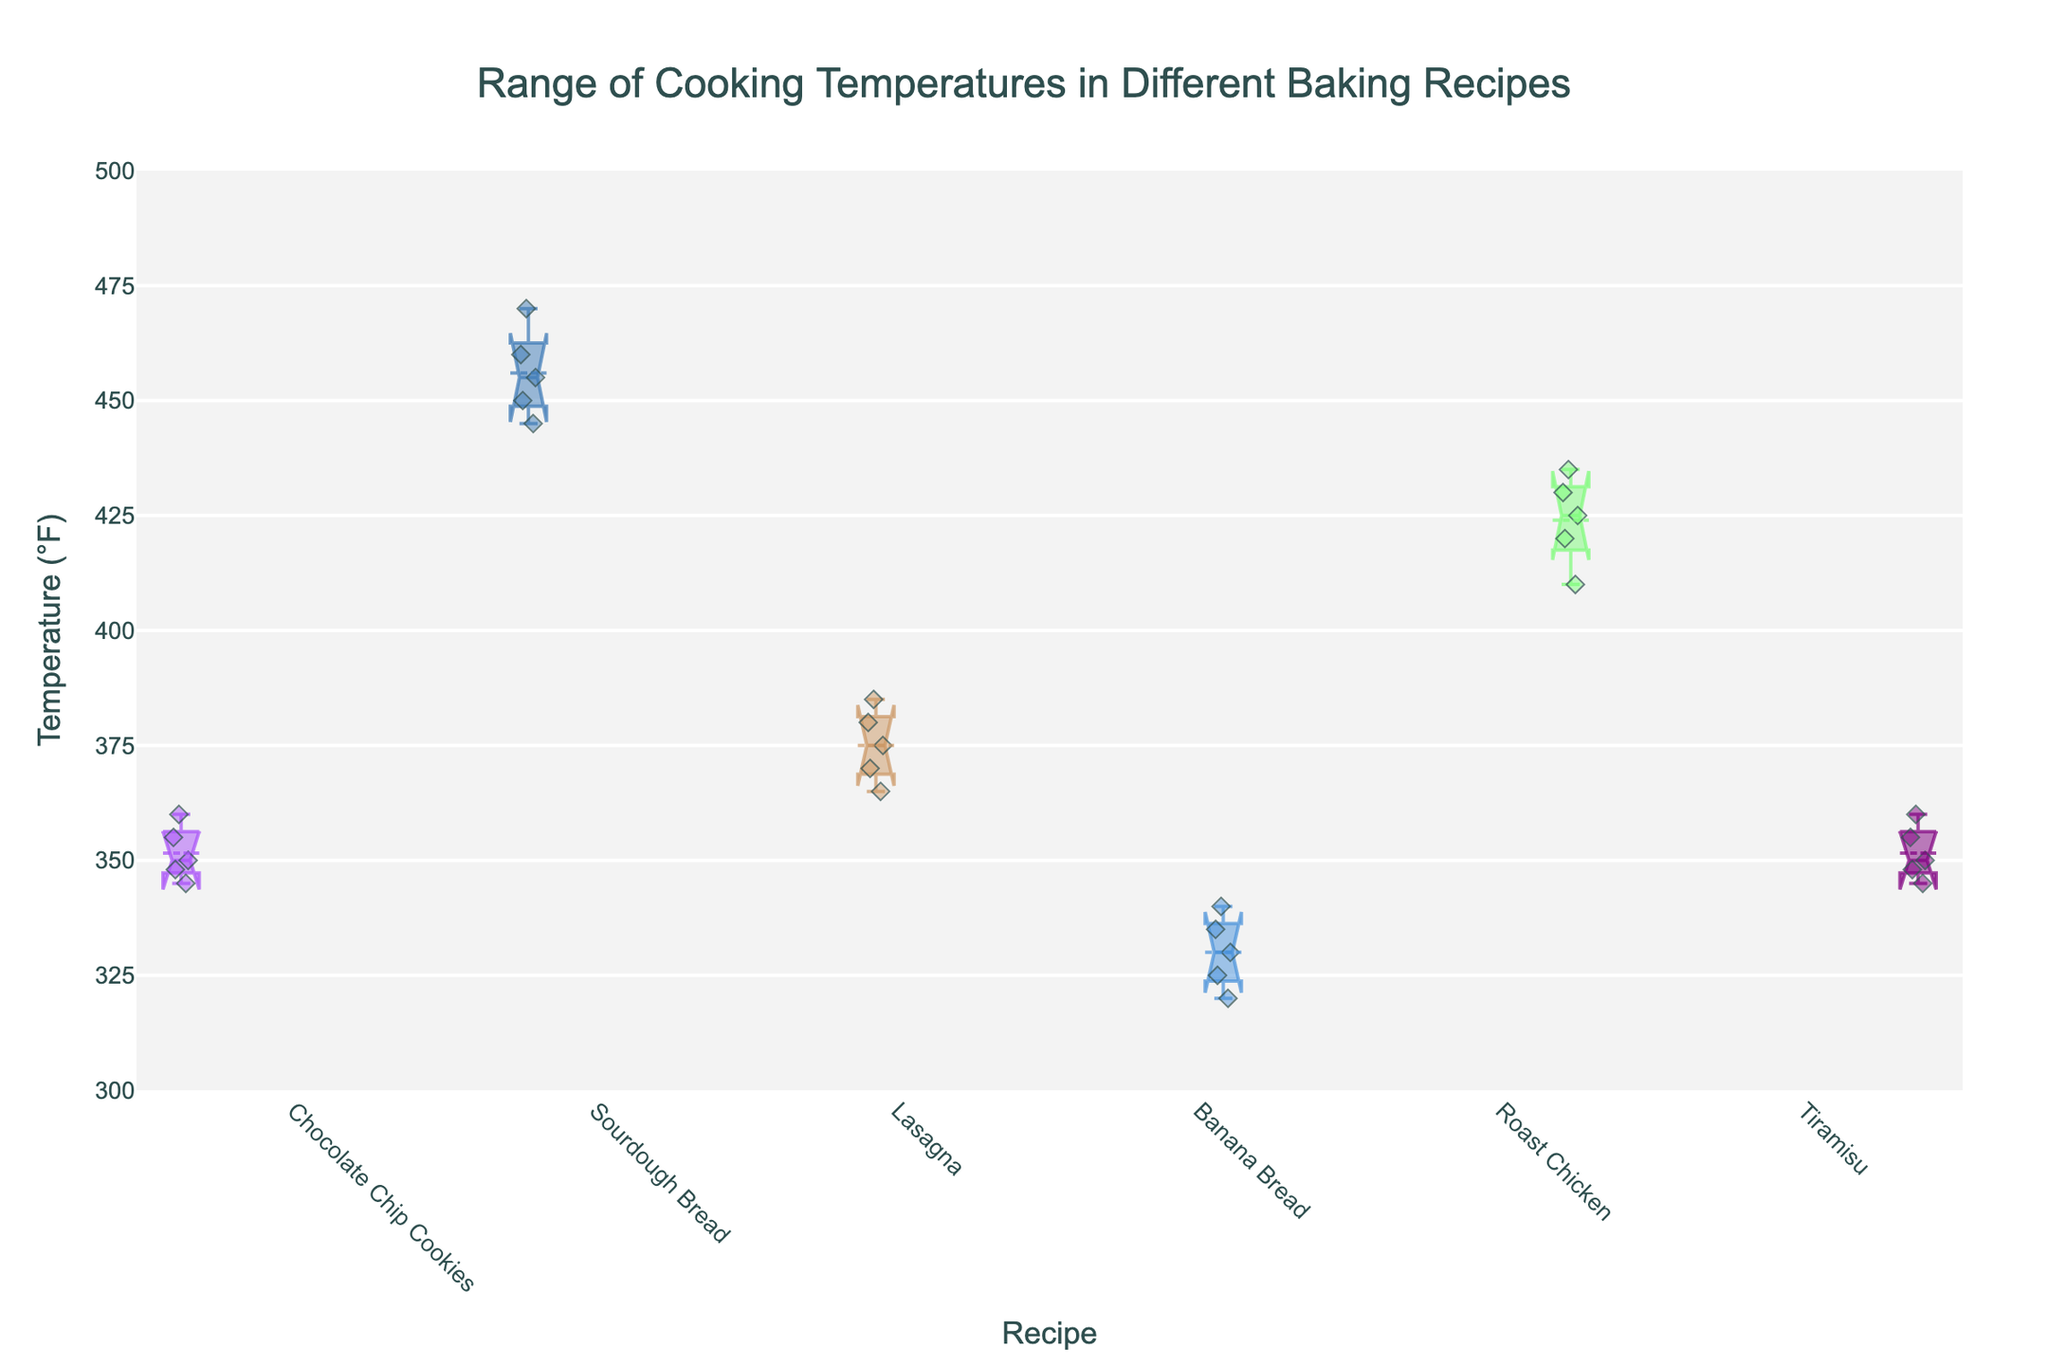What's the title of the plot? The plot's title is given at the top center of the figure and usually summarizes the main topic of the data visualization. It's written in a larger and bold font to grab attention.
Answer: Range of Cooking Temperatures in Different Baking Recipes What is the range of temperatures for Chocolate Chip Cookies? The range of temperatures for a recipe can be observed by looking at the box plot for that recipe. The whiskers of the box indicate the minimum and maximum values. For Chocolate Chip Cookies, it extends from 345°F to 360°F.
Answer: 345°F - 360°F Which recipe has the highest median cooking temperature? The median of each recipe is represented by the line inside the box plot. The highest median can be identified by looking for the highest positioned line. The median for Sourdough Bread appears to be the highest.
Answer: Sourdough Bread What colors are used for the markers in this plot? Each recipe is plotted with a unique color for the markers. The colors are specific to each recipe and are typically displayed as variations of RGBA colors, but here they appear as different shades. The color's exact notation from the code is not necessary to identify this visually.
Answer: Various unique colors Are there any outliers in the Banana Bread data? In a box plot, outliers are represented by individual points outside the whiskers. For Banana Bread, no individual points appear to be outside the whiskers.
Answer: No What recipe has the narrowest interquartile range (IQR)? The interquartile range (IQR) is the difference between the 25th and 75th percentile. The narrowest IQR can be identified by the width of the box itself in the box plot. Lasagna has the narrowest IQR.
Answer: Lasagna Which recipe has the most variability in cooking temperature? Variability can be assessed by the range between the whiskers or the IQR. The recipe with the widest whiskers or largest IQR indicates more variability. Sourdough Bread has the largest range between its whiskers.
Answer: Sourdough Bread Compare the median cooking temperatures of Lasagna and Banana Bread. Which is higher? Comparing the medians involves looking at the line in the center of the box for each recipe. The line representing the median for Lasagna is higher than that for Banana Bread.
Answer: Lasagna How does the temperature range for Roast Chicken compare to Tiramisu? Comparing the whisker spans of both recipes shows the range of temperatures. Roast Chicken's range (410°F - 435°F) is higher than Tiramisu's (345°F - 360°F).
Answer: Roast Chicken is higher What is the median cooking temperature for Tiramisu? The median temperature can be located by finding the line within the box of the Tiramisu plot. The median value lies around 350°F.
Answer: 350°F 